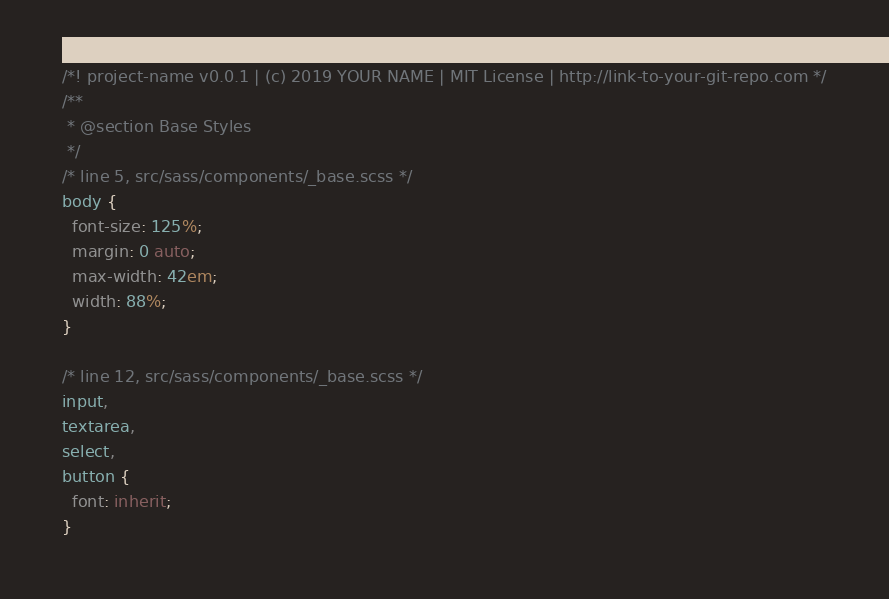<code> <loc_0><loc_0><loc_500><loc_500><_CSS_>/*! project-name v0.0.1 | (c) 2019 YOUR NAME | MIT License | http://link-to-your-git-repo.com */
/**
 * @section Base Styles
 */
/* line 5, src/sass/components/_base.scss */
body {
  font-size: 125%;
  margin: 0 auto;
  max-width: 42em;
  width: 88%;
}

/* line 12, src/sass/components/_base.scss */
input,
textarea,
select,
button {
  font: inherit;
}
</code> 